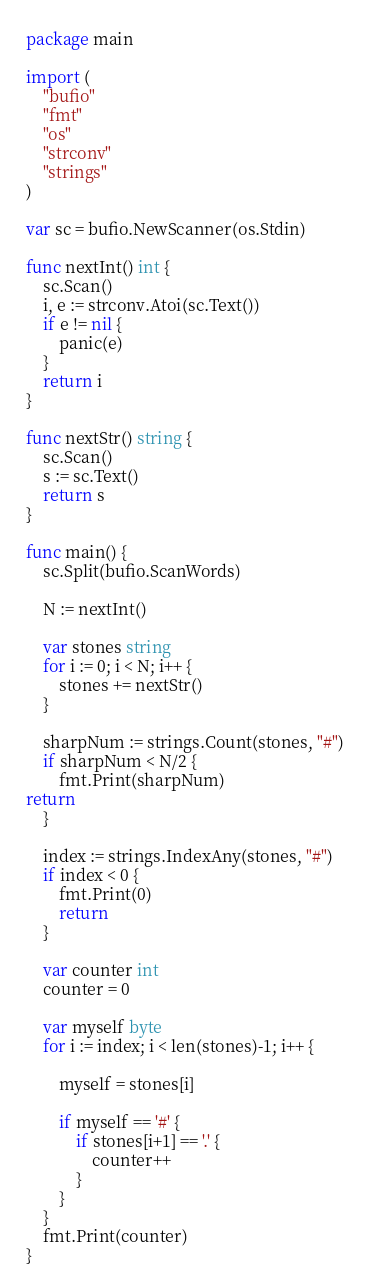Convert code to text. <code><loc_0><loc_0><loc_500><loc_500><_Go_>package main

import (
	"bufio"
	"fmt"
	"os"
	"strconv"
	"strings"
)

var sc = bufio.NewScanner(os.Stdin)

func nextInt() int {
	sc.Scan()
	i, e := strconv.Atoi(sc.Text())
	if e != nil {
		panic(e)
	}
	return i
}

func nextStr() string {
	sc.Scan()
	s := sc.Text()
	return s
}

func main() {
	sc.Split(bufio.ScanWords)

	N := nextInt()

	var stones string
	for i := 0; i < N; i++ {
		stones += nextStr()
	}

	sharpNum := strings.Count(stones, "#")
	if sharpNum < N/2 {
		fmt.Print(sharpNum)
return
	}

	index := strings.IndexAny(stones, "#")
	if index < 0 {
		fmt.Print(0)
		return
	}

	var counter int
	counter = 0

	var myself byte
	for i := index; i < len(stones)-1; i++ {

		myself = stones[i]

		if myself == '#' {
			if stones[i+1] == '.' {
				counter++
			}
		}
	}
	fmt.Print(counter)
}
</code> 